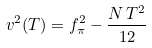Convert formula to latex. <formula><loc_0><loc_0><loc_500><loc_500>v ^ { 2 } ( T ) = f _ { \pi } ^ { 2 } - \frac { N \, T ^ { 2 } } { 1 2 }</formula> 